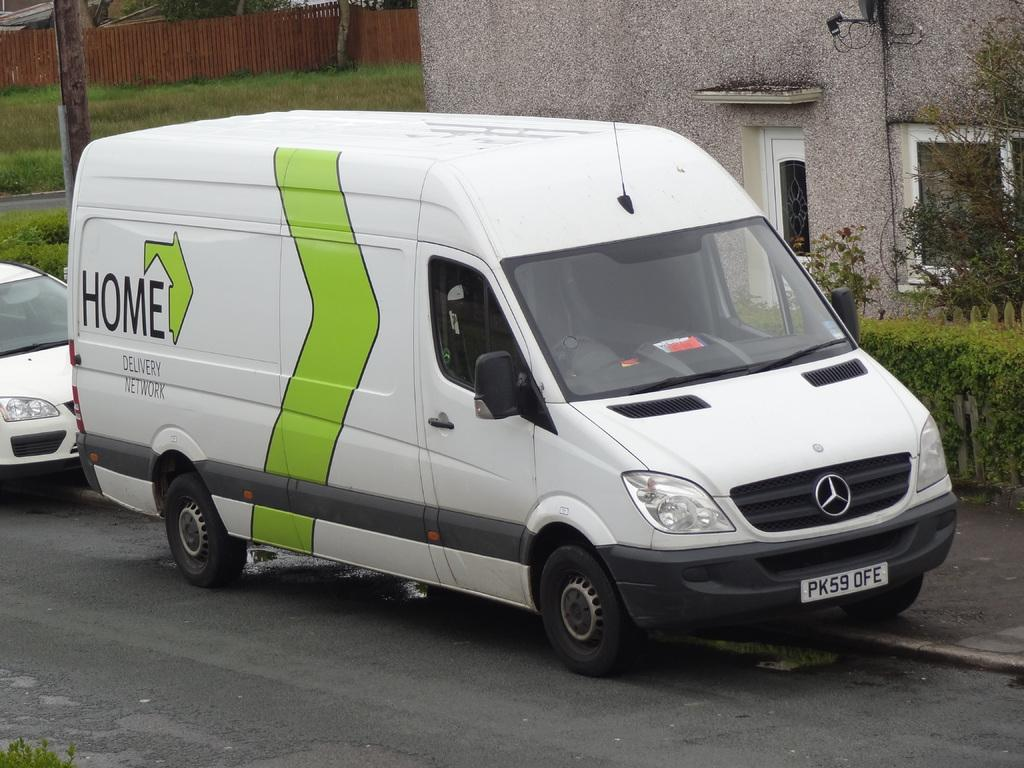<image>
Provide a brief description of the given image. a van with has a PK on the license plate 